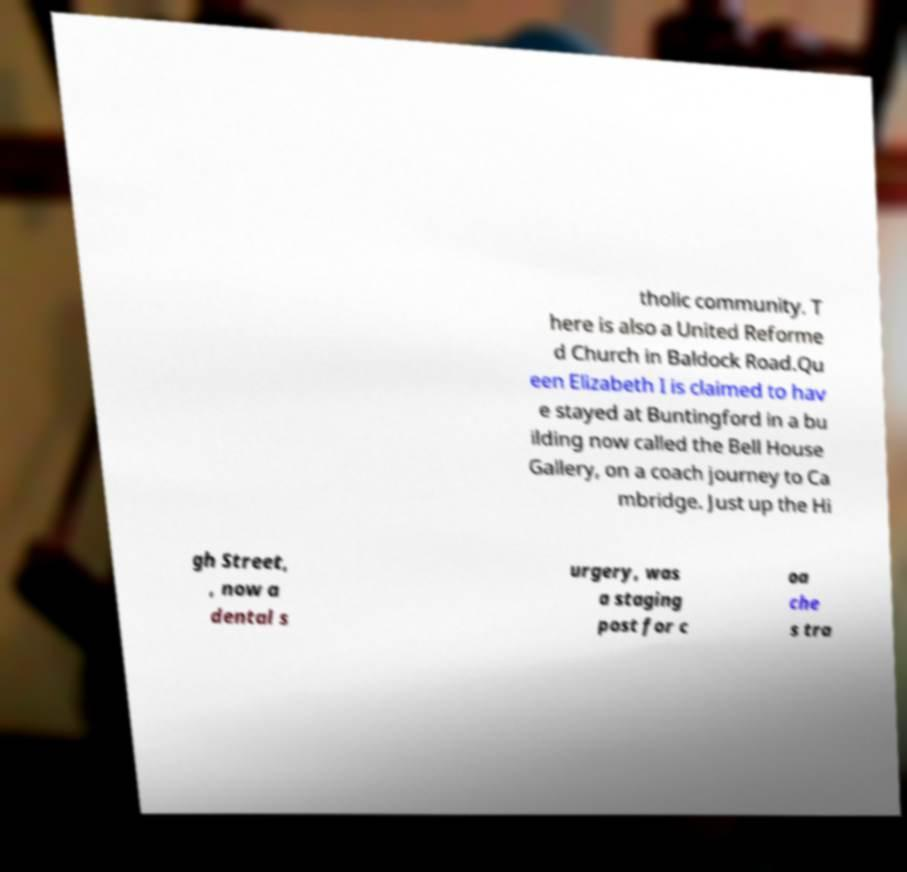Please read and relay the text visible in this image. What does it say? tholic community. T here is also a United Reforme d Church in Baldock Road.Qu een Elizabeth I is claimed to hav e stayed at Buntingford in a bu ilding now called the Bell House Gallery, on a coach journey to Ca mbridge. Just up the Hi gh Street, , now a dental s urgery, was a staging post for c oa che s tra 